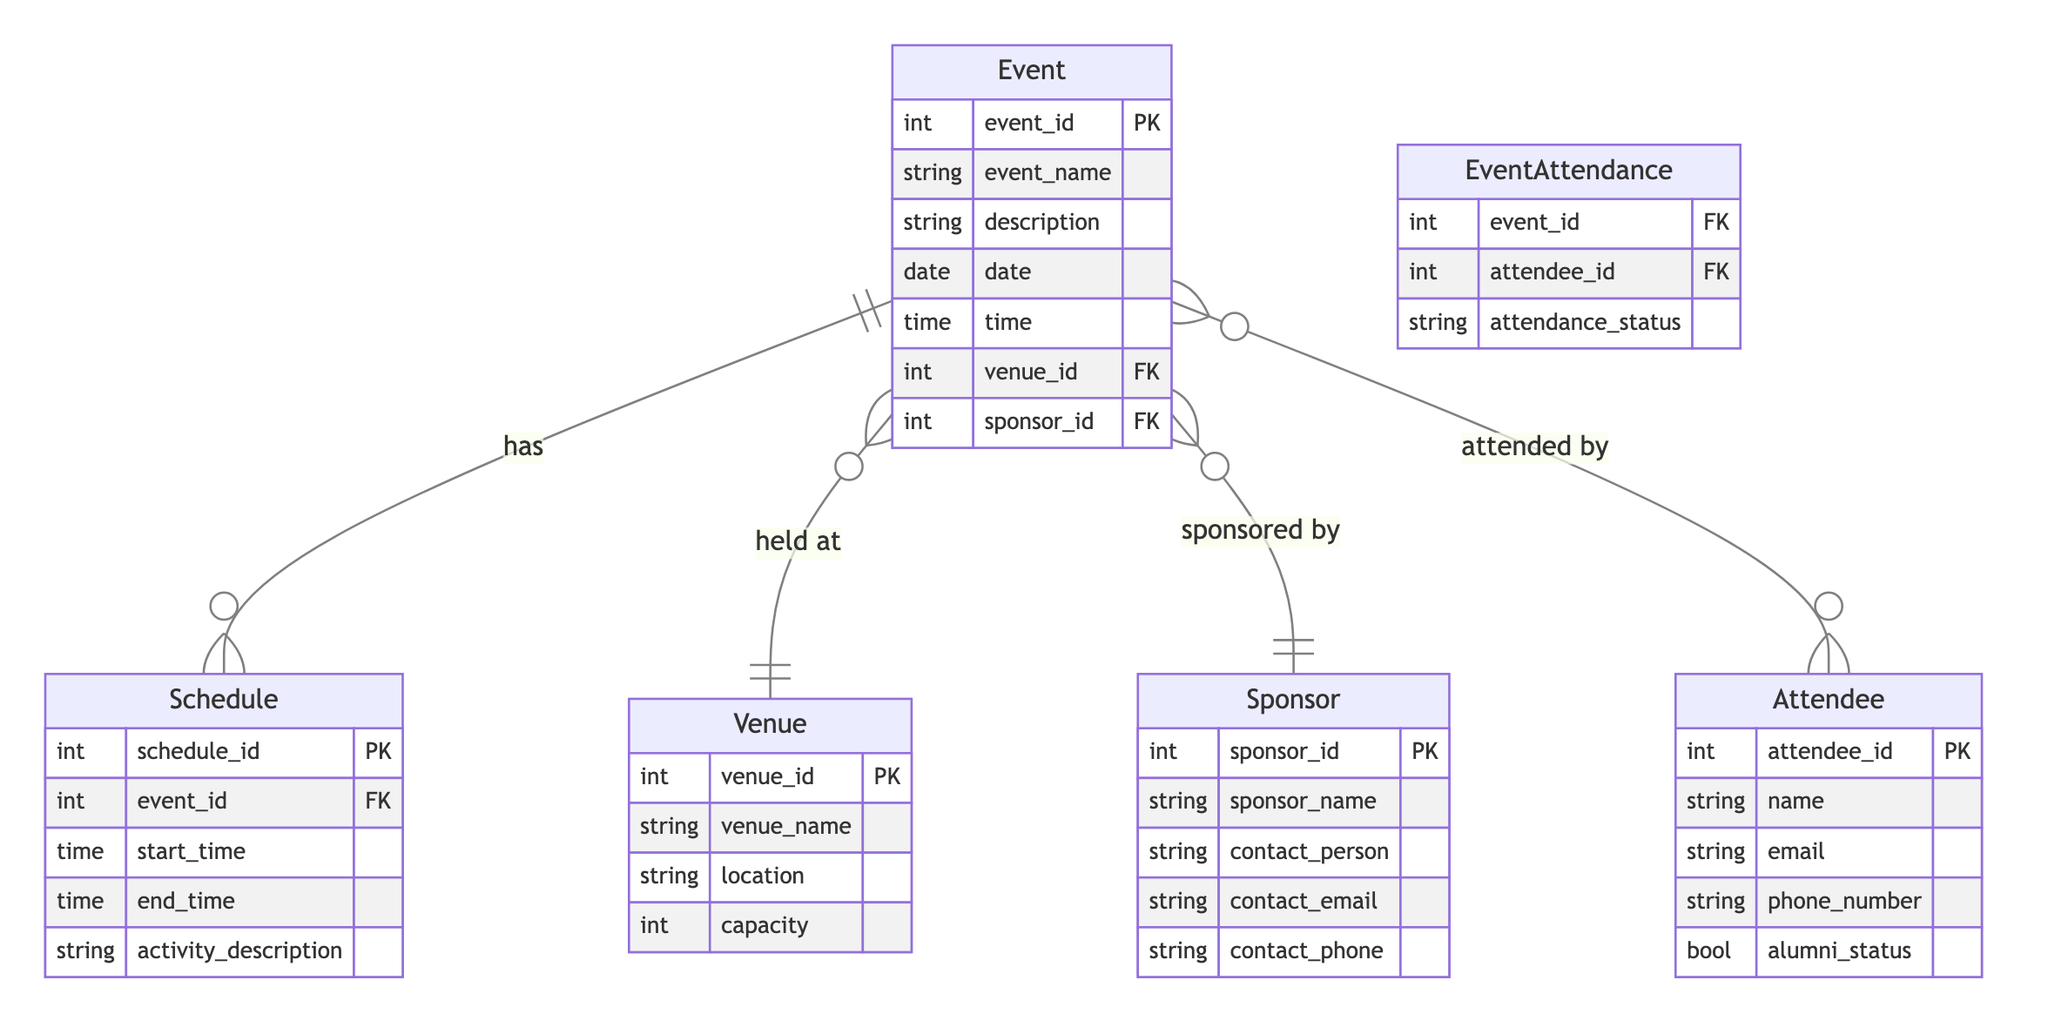What is the primary key of the Event entity? The primary key for the Event entity is defined as "event_id", which uniquely identifies each event in the database.
Answer: event_id How many entities are there in the diagram? The diagram lists five distinct entities: Event, Attendee, Venue, Sponsor, and Schedule. Counting these gives a total of five entities.
Answer: five What is the relationship type between Event and Attendee? The relationship between Event and Attendee is a many-to-many relationship, indicated by the notation showing both entities having multiple connections to each other.
Answer: many-to-many Which entity is involved in the EventSchedule relationship? The entity involved in the EventSchedule relationship is the Schedule, indicated by the one-to-many notation between Event and Schedule.
Answer: Schedule What attribute describes the capacity of a Venue? The attribute that describes the capacity of a Venue is "capacity", which indicates how many individuals the venue can accommodate.
Answer: capacity How many relationship types are shown in the diagram? There are four different relationship types detailed in the diagram: EventAttendance, EventVenue, EventSponsorship, and EventSchedule, making a total of four.
Answer: four Which entity is responsible for sponsorship of an Event? The entity responsible for sponsorship of an Event is the Sponsor, as indicated by the "sponsored by" relationship from Event to Sponsor.
Answer: Sponsor What is the attendance status attribute related to? The attendance status attribute is related to the EventAttendance relationship, which connects attendees to events and defines their attendance status.
Answer: EventAttendance What does the Schedule entity detail about an Event? The Schedule entity details the start and end times of an event, along with a description of the activities that will occur during that time frame.
Answer: start time, end time, activity description 